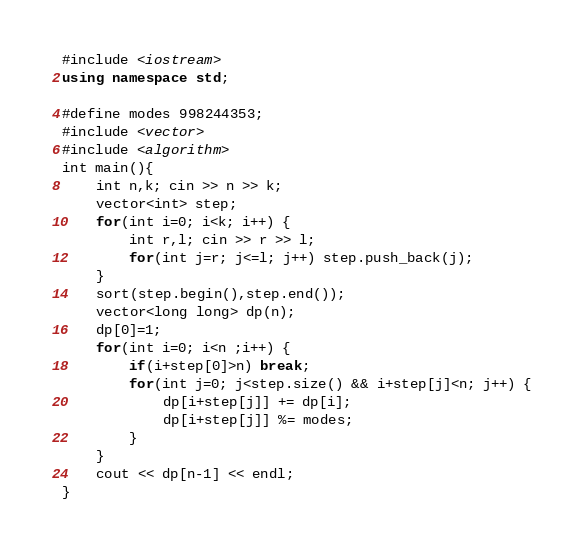<code> <loc_0><loc_0><loc_500><loc_500><_C++_>#include <iostream>
using namespace std;

#define modes 998244353;
#include <vector>
#include <algorithm>
int main(){
    int n,k; cin >> n >> k;
    vector<int> step;
    for(int i=0; i<k; i++) {
        int r,l; cin >> r >> l;
        for(int j=r; j<=l; j++) step.push_back(j);
    }
    sort(step.begin(),step.end());
    vector<long long> dp(n);
    dp[0]=1;
    for(int i=0; i<n ;i++) {
        if(i+step[0]>n) break;
        for(int j=0; j<step.size() && i+step[j]<n; j++) {
            dp[i+step[j]] += dp[i];
            dp[i+step[j]] %= modes;
        }
    }
    cout << dp[n-1] << endl;
}</code> 